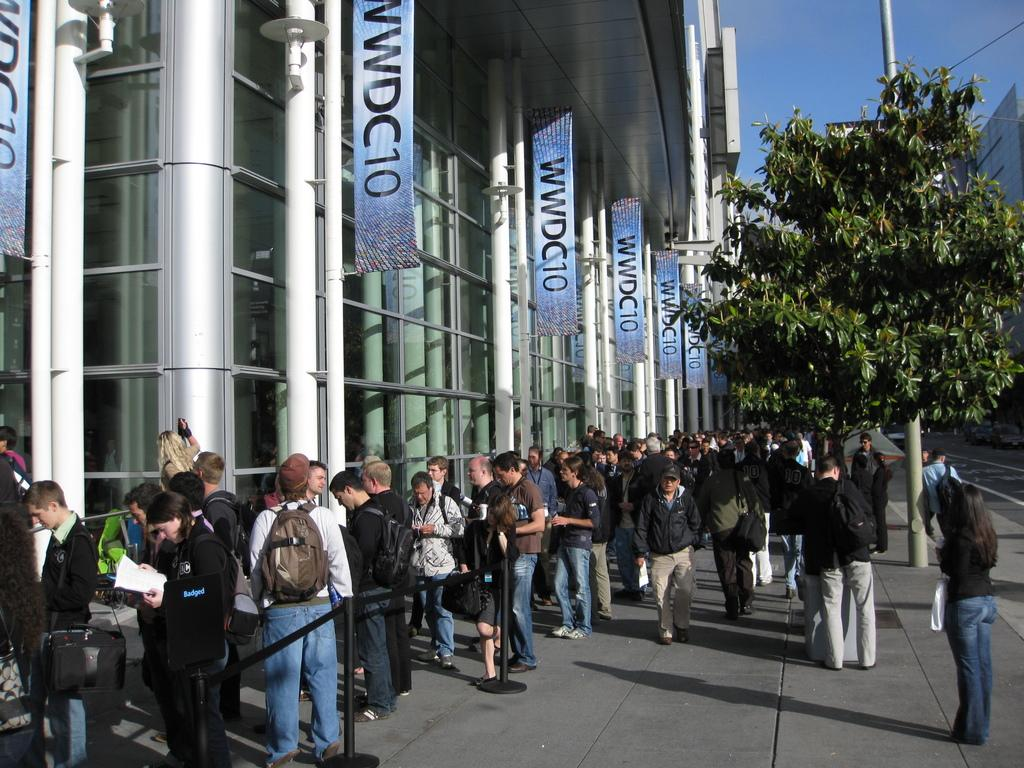<image>
Present a compact description of the photo's key features. a building with sign on the side of it that say 'wwdc10' 